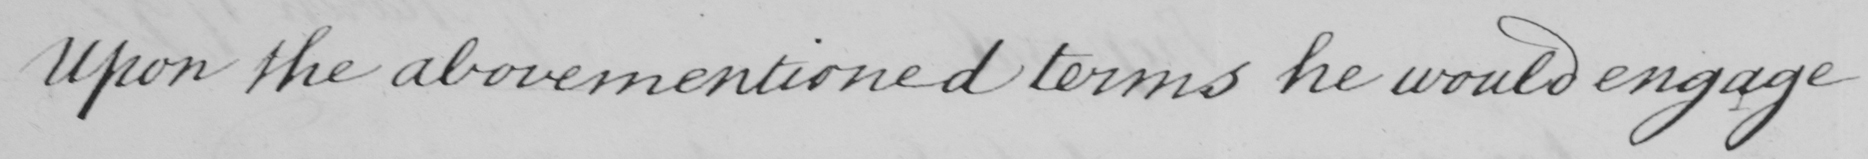Please transcribe the handwritten text in this image. upon the abovementioned terms he would engage 